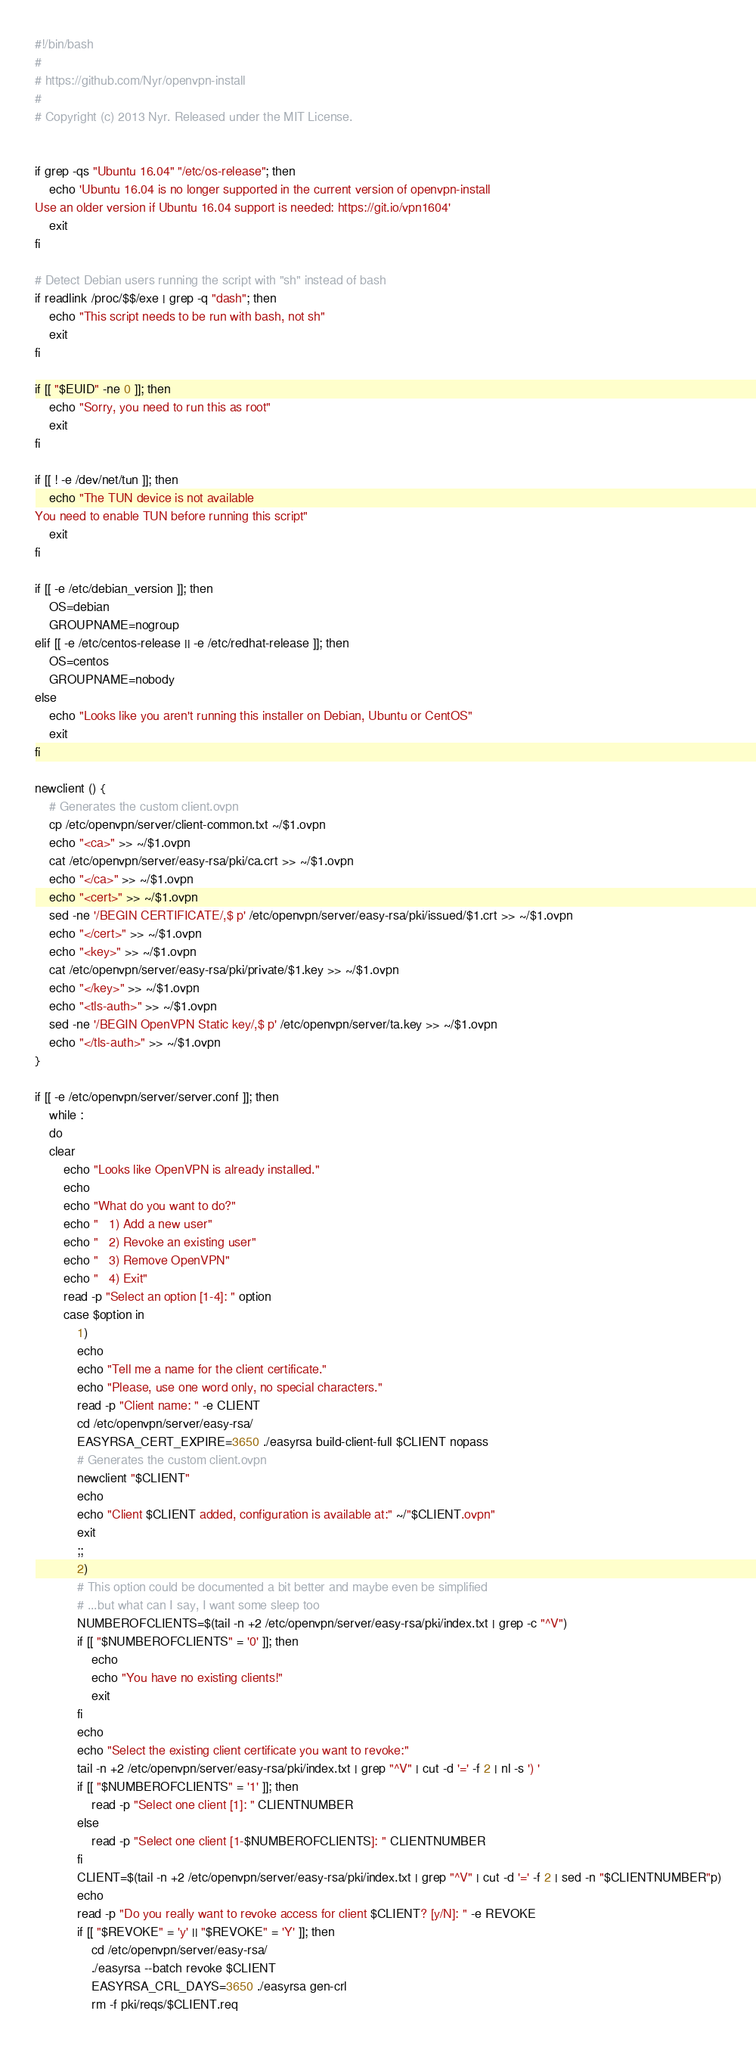<code> <loc_0><loc_0><loc_500><loc_500><_Bash_>#!/bin/bash
#
# https://github.com/Nyr/openvpn-install
#
# Copyright (c) 2013 Nyr. Released under the MIT License.


if grep -qs "Ubuntu 16.04" "/etc/os-release"; then
	echo 'Ubuntu 16.04 is no longer supported in the current version of openvpn-install
Use an older version if Ubuntu 16.04 support is needed: https://git.io/vpn1604'
	exit
fi

# Detect Debian users running the script with "sh" instead of bash
if readlink /proc/$$/exe | grep -q "dash"; then
	echo "This script needs to be run with bash, not sh"
	exit
fi

if [[ "$EUID" -ne 0 ]]; then
	echo "Sorry, you need to run this as root"
	exit
fi

if [[ ! -e /dev/net/tun ]]; then
	echo "The TUN device is not available
You need to enable TUN before running this script"
	exit
fi

if [[ -e /etc/debian_version ]]; then
	OS=debian
	GROUPNAME=nogroup
elif [[ -e /etc/centos-release || -e /etc/redhat-release ]]; then
	OS=centos
	GROUPNAME=nobody
else
	echo "Looks like you aren't running this installer on Debian, Ubuntu or CentOS"
	exit
fi

newclient () {
	# Generates the custom client.ovpn
	cp /etc/openvpn/server/client-common.txt ~/$1.ovpn
	echo "<ca>" >> ~/$1.ovpn
	cat /etc/openvpn/server/easy-rsa/pki/ca.crt >> ~/$1.ovpn
	echo "</ca>" >> ~/$1.ovpn
	echo "<cert>" >> ~/$1.ovpn
	sed -ne '/BEGIN CERTIFICATE/,$ p' /etc/openvpn/server/easy-rsa/pki/issued/$1.crt >> ~/$1.ovpn
	echo "</cert>" >> ~/$1.ovpn
	echo "<key>" >> ~/$1.ovpn
	cat /etc/openvpn/server/easy-rsa/pki/private/$1.key >> ~/$1.ovpn
	echo "</key>" >> ~/$1.ovpn
	echo "<tls-auth>" >> ~/$1.ovpn
	sed -ne '/BEGIN OpenVPN Static key/,$ p' /etc/openvpn/server/ta.key >> ~/$1.ovpn
	echo "</tls-auth>" >> ~/$1.ovpn
}

if [[ -e /etc/openvpn/server/server.conf ]]; then
	while :
	do
	clear
		echo "Looks like OpenVPN is already installed."
		echo
		echo "What do you want to do?"
		echo "   1) Add a new user"
		echo "   2) Revoke an existing user"
		echo "   3) Remove OpenVPN"
		echo "   4) Exit"
		read -p "Select an option [1-4]: " option
		case $option in
			1) 
			echo
			echo "Tell me a name for the client certificate."
			echo "Please, use one word only, no special characters."
			read -p "Client name: " -e CLIENT
			cd /etc/openvpn/server/easy-rsa/
			EASYRSA_CERT_EXPIRE=3650 ./easyrsa build-client-full $CLIENT nopass
			# Generates the custom client.ovpn
			newclient "$CLIENT"
			echo
			echo "Client $CLIENT added, configuration is available at:" ~/"$CLIENT.ovpn"
			exit
			;;
			2)
			# This option could be documented a bit better and maybe even be simplified
			# ...but what can I say, I want some sleep too
			NUMBEROFCLIENTS=$(tail -n +2 /etc/openvpn/server/easy-rsa/pki/index.txt | grep -c "^V")
			if [[ "$NUMBEROFCLIENTS" = '0' ]]; then
				echo
				echo "You have no existing clients!"
				exit
			fi
			echo
			echo "Select the existing client certificate you want to revoke:"
			tail -n +2 /etc/openvpn/server/easy-rsa/pki/index.txt | grep "^V" | cut -d '=' -f 2 | nl -s ') '
			if [[ "$NUMBEROFCLIENTS" = '1' ]]; then
				read -p "Select one client [1]: " CLIENTNUMBER
			else
				read -p "Select one client [1-$NUMBEROFCLIENTS]: " CLIENTNUMBER
			fi
			CLIENT=$(tail -n +2 /etc/openvpn/server/easy-rsa/pki/index.txt | grep "^V" | cut -d '=' -f 2 | sed -n "$CLIENTNUMBER"p)
			echo
			read -p "Do you really want to revoke access for client $CLIENT? [y/N]: " -e REVOKE
			if [[ "$REVOKE" = 'y' || "$REVOKE" = 'Y' ]]; then
				cd /etc/openvpn/server/easy-rsa/
				./easyrsa --batch revoke $CLIENT
				EASYRSA_CRL_DAYS=3650 ./easyrsa gen-crl
				rm -f pki/reqs/$CLIENT.req</code> 